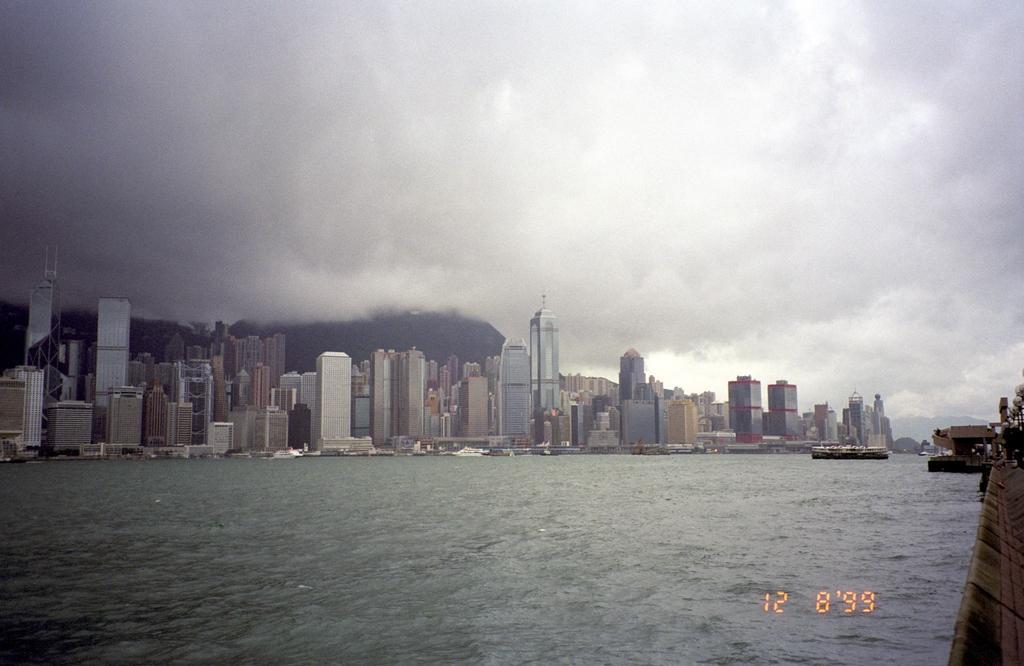Describe this image in one or two sentences. This is the picture of a city. In this image there are buildings and there are boats on the water. At the back it looks like a mountain. On the right side of the image there are street lights and there is a tree. At the top there is sky and there are clouds. At the bottom there is water. 